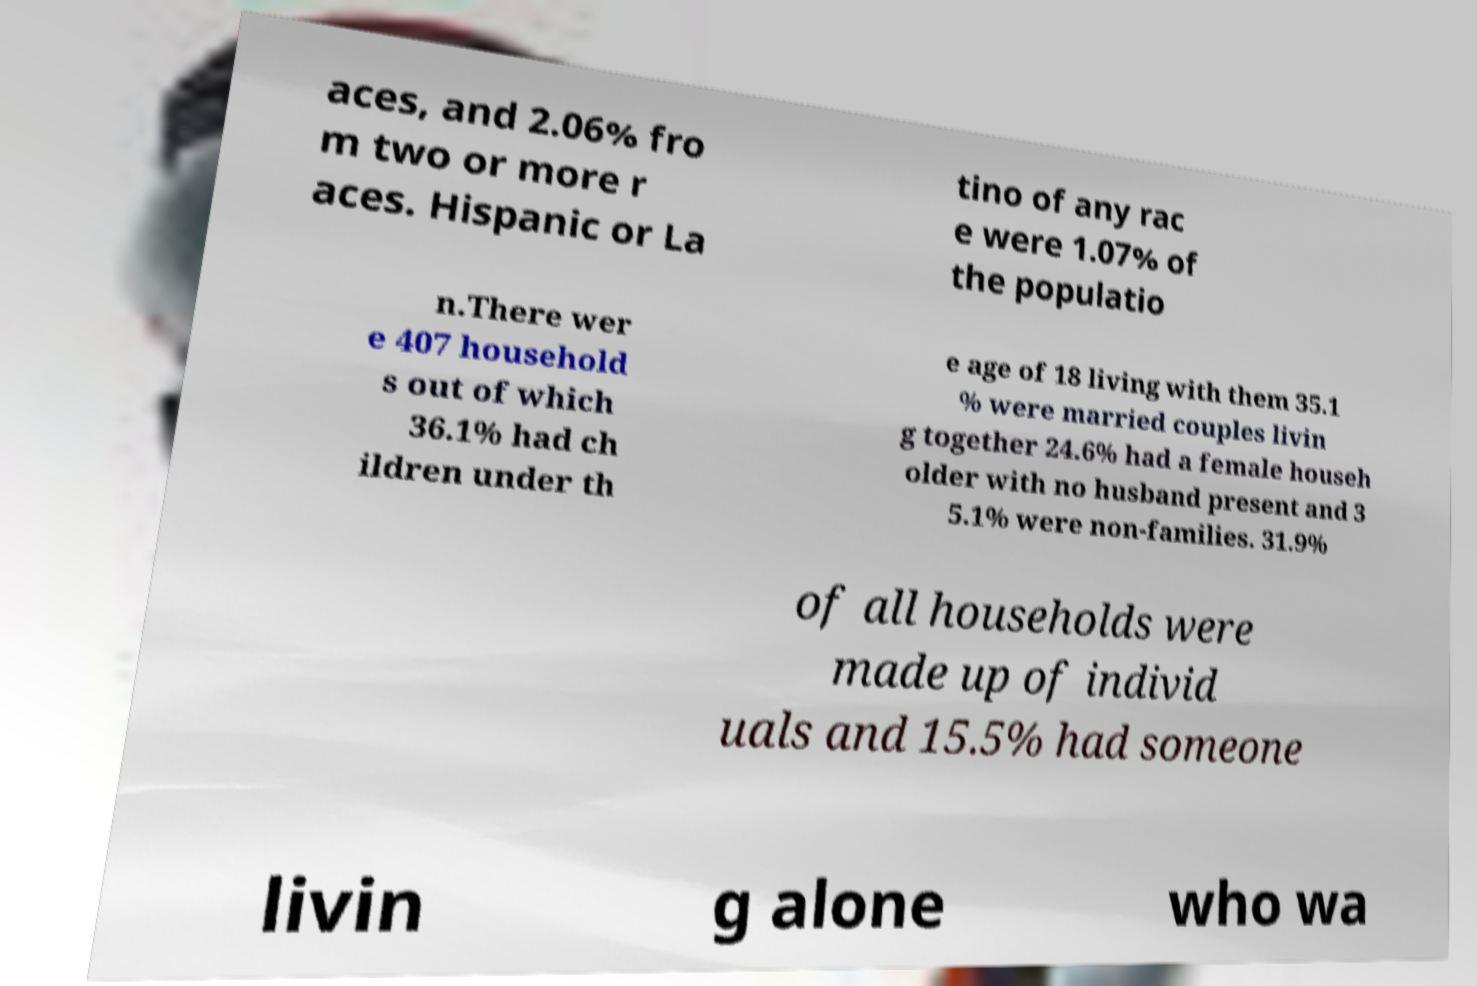Can you accurately transcribe the text from the provided image for me? aces, and 2.06% fro m two or more r aces. Hispanic or La tino of any rac e were 1.07% of the populatio n.There wer e 407 household s out of which 36.1% had ch ildren under th e age of 18 living with them 35.1 % were married couples livin g together 24.6% had a female househ older with no husband present and 3 5.1% were non-families. 31.9% of all households were made up of individ uals and 15.5% had someone livin g alone who wa 